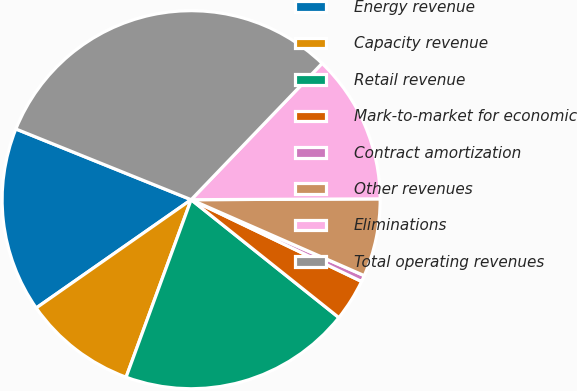<chart> <loc_0><loc_0><loc_500><loc_500><pie_chart><fcel>Energy revenue<fcel>Capacity revenue<fcel>Retail revenue<fcel>Mark-to-market for economic<fcel>Contract amortization<fcel>Other revenues<fcel>Eliminations<fcel>Total operating revenues<nl><fcel>15.81%<fcel>9.7%<fcel>19.87%<fcel>3.6%<fcel>0.54%<fcel>6.65%<fcel>12.75%<fcel>31.07%<nl></chart> 